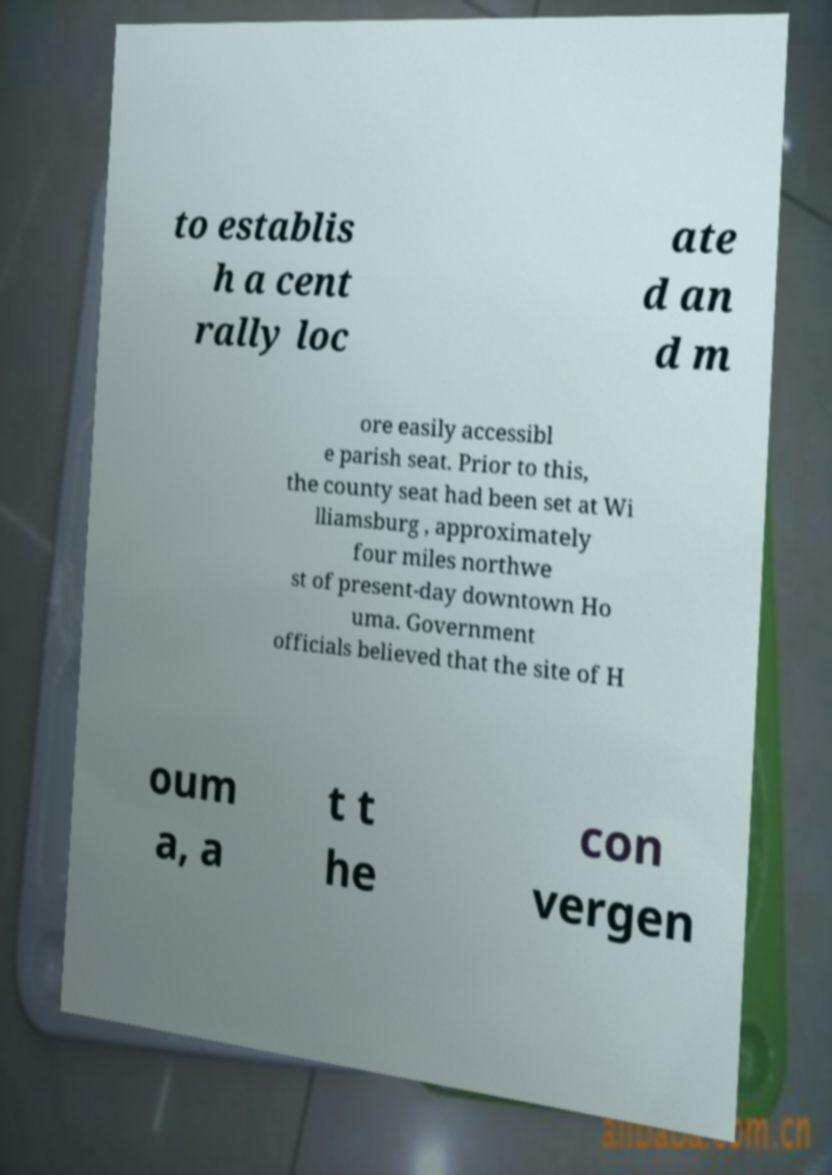Please read and relay the text visible in this image. What does it say? to establis h a cent rally loc ate d an d m ore easily accessibl e parish seat. Prior to this, the county seat had been set at Wi lliamsburg , approximately four miles northwe st of present-day downtown Ho uma. Government officials believed that the site of H oum a, a t t he con vergen 